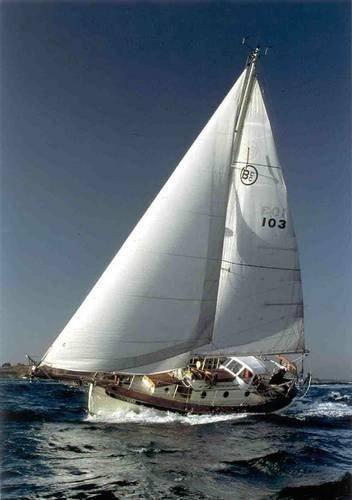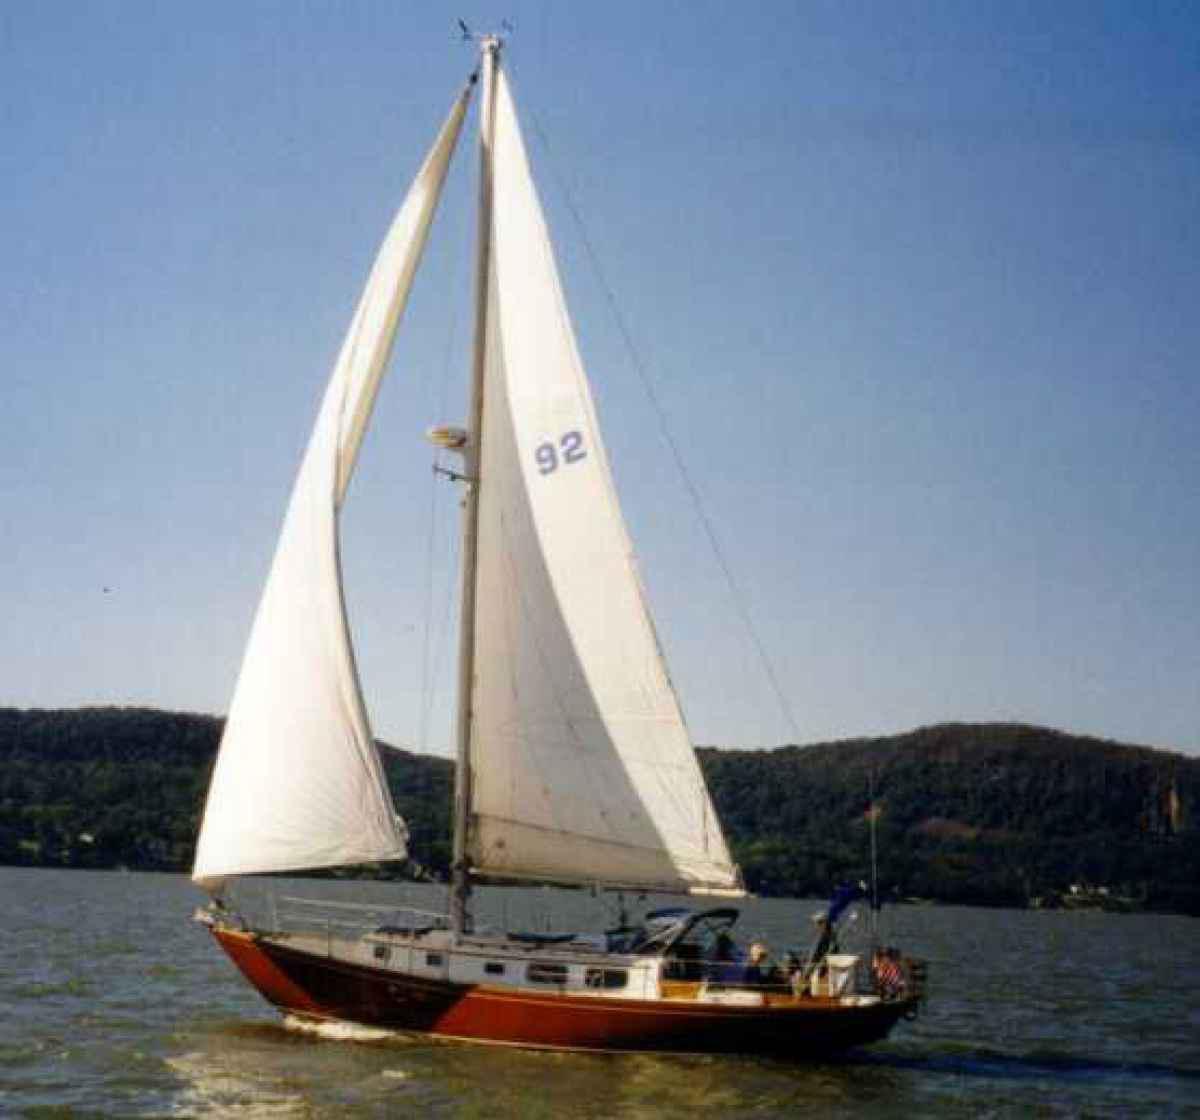The first image is the image on the left, the second image is the image on the right. Assess this claim about the two images: "The left and right image contains the same number of sailboat sailing on the water in opposite directions.". Correct or not? Answer yes or no. Yes. The first image is the image on the left, the second image is the image on the right. Examine the images to the left and right. Is the description "One of the boats has three opened sails." accurate? Answer yes or no. No. 